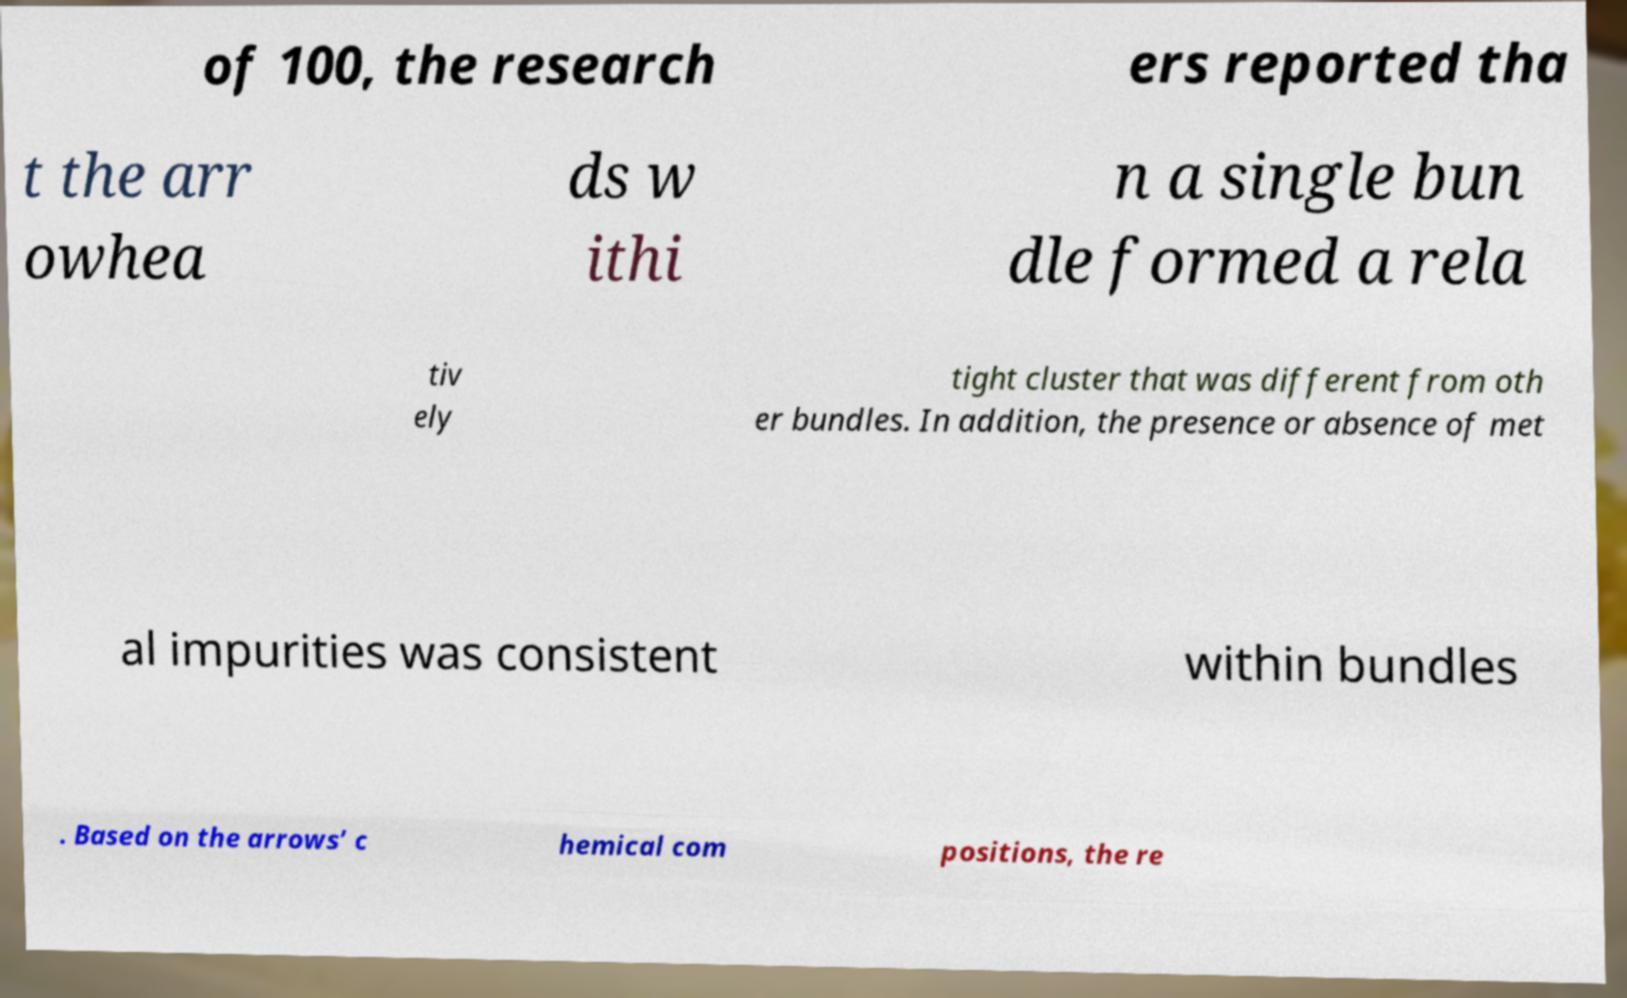Please identify and transcribe the text found in this image. of 100, the research ers reported tha t the arr owhea ds w ithi n a single bun dle formed a rela tiv ely tight cluster that was different from oth er bundles. In addition, the presence or absence of met al impurities was consistent within bundles . Based on the arrows’ c hemical com positions, the re 